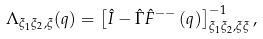Convert formula to latex. <formula><loc_0><loc_0><loc_500><loc_500>\Lambda _ { \xi _ { 1 } \xi _ { 2 } , \xi } ( q ) = \left [ \hat { I } - \hat { \Gamma } \hat { F } ^ { - - } \left ( q \right ) \right ] _ { \xi _ { 1 } \xi _ { 2 } , \xi \xi } ^ { - 1 } ,</formula> 